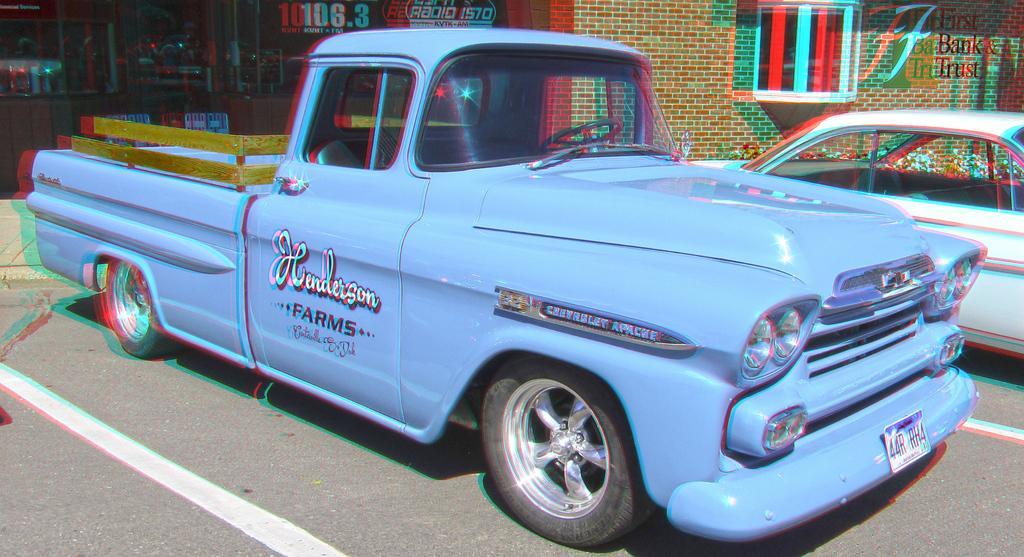How would you summarize this image in a sentence or two? In this picture we can see blue color car on the road. On the right we can see white color car near to the building. On the top right corner we can see watermark and window. On the top left corner we can see glass doors. 